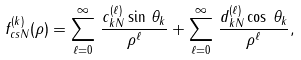<formula> <loc_0><loc_0><loc_500><loc_500>f _ { c s N } ^ { ( k ) } ( \rho ) = \sum _ { \ell = 0 } ^ { \infty } \, \frac { c _ { k N } ^ { ( \ell ) } \sin \, \theta _ { k } } { \rho ^ { \ell } } + \sum _ { \ell = 0 } ^ { \infty } \, \frac { d _ { k N } ^ { ( \ell ) } \cos \, \theta _ { k } } { \rho ^ { \ell } } ,</formula> 